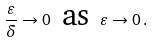Convert formula to latex. <formula><loc_0><loc_0><loc_500><loc_500>\frac { \varepsilon } { \delta } \rightarrow 0 \, \text { as } \, \varepsilon \rightarrow 0 \, .</formula> 